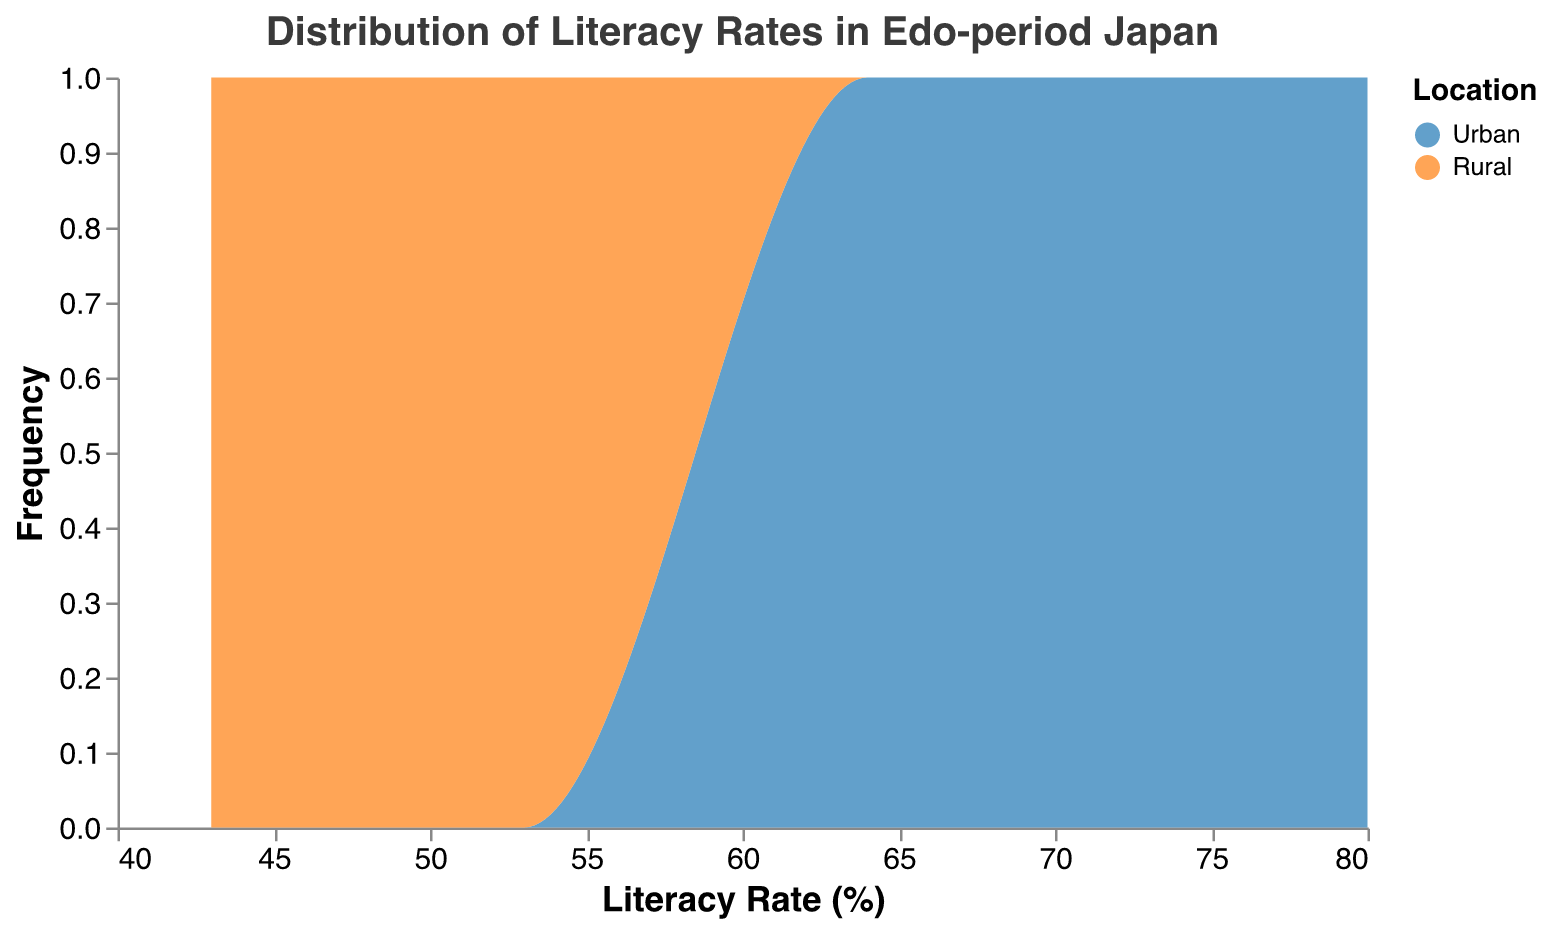What is the title of the figure? The title is displayed prominently at the top of the plot. It helps to give an immediate understanding of the content of the plot.
Answer: Distribution of Literacy Rates in Edo-period Japan What are the colors representing urban and rural locations? The figure uses a legend to differentiate between urban and rural locations using different colors. Urban areas are represented by blue, and rural areas are represented by orange.
Answer: Blue and Orange How many urban locations are there in the data? By counting the instances where "Location" is labeled as "Urban" in the plot, we can determine the number of urban locations. There are 11 such entries.
Answer: 11 How does the distribution of literacy rates differ between urban and rural locations? By observing the plot, the urban literacy rates are generally higher and more concentrated between 64% to 80%, while rural literacy rates are lower and spread across 43% to 53%.
Answer: Urban literacy rates are higher and more concentrated What is the peak frequency of literacy rates for rural areas? The peak frequency for rural literacy rates is found by observing the highest point of the area curve specific to the orange color. This peak occurs around the 48% to 53% literacy rate range.
Answer: 48% to 53% What is the difference in the highest recorded literacy rates between urban and rural areas? The highest urban literacy rate is 80%, and the highest rural literacy rate is 53%. The difference is calculated by subtracting 53 from 80, which gives 27.
Answer: 27% Is there a larger variation in literacy rates in urban or rural areas? By observing the spread of the distribution, urban literacy rates vary from 64% to 80%, whereas rural literacy rates vary from 43% to 53%. This indicates a larger variation in urban areas.
Answer: Urban areas At which literacy rate do both urban and rural distributions start to overlap? Observing where the blue and orange curves begin to show common areas, we see some overlap starting to appear around the 64-66% mark.
Answer: 64-66% What is the median literacy rate for rural areas? By identifying the middle value in the distribution of rural literacy rates from the plot, the middle value is 47%.
Answer: 47% 